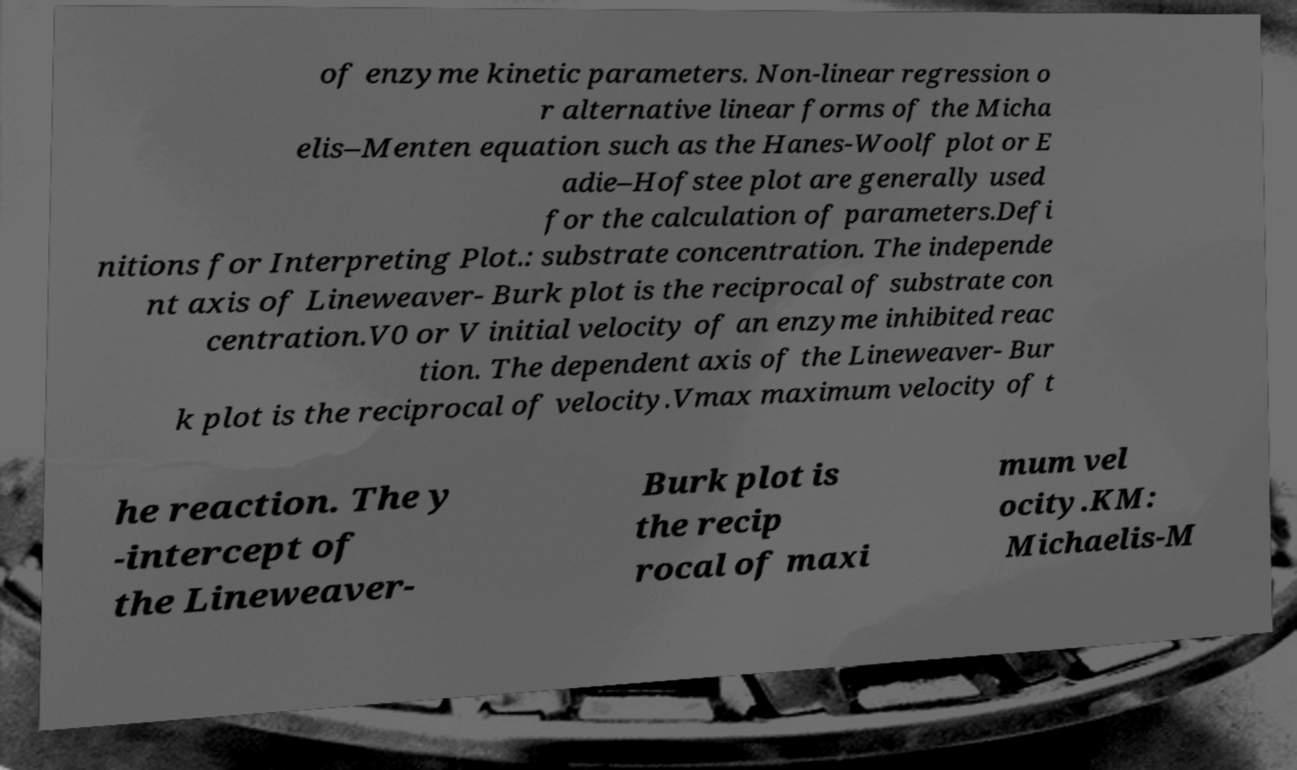Could you assist in decoding the text presented in this image and type it out clearly? of enzyme kinetic parameters. Non-linear regression o r alternative linear forms of the Micha elis–Menten equation such as the Hanes-Woolf plot or E adie–Hofstee plot are generally used for the calculation of parameters.Defi nitions for Interpreting Plot.: substrate concentration. The independe nt axis of Lineweaver- Burk plot is the reciprocal of substrate con centration.V0 or V initial velocity of an enzyme inhibited reac tion. The dependent axis of the Lineweaver- Bur k plot is the reciprocal of velocity.Vmax maximum velocity of t he reaction. The y -intercept of the Lineweaver- Burk plot is the recip rocal of maxi mum vel ocity.KM: Michaelis-M 